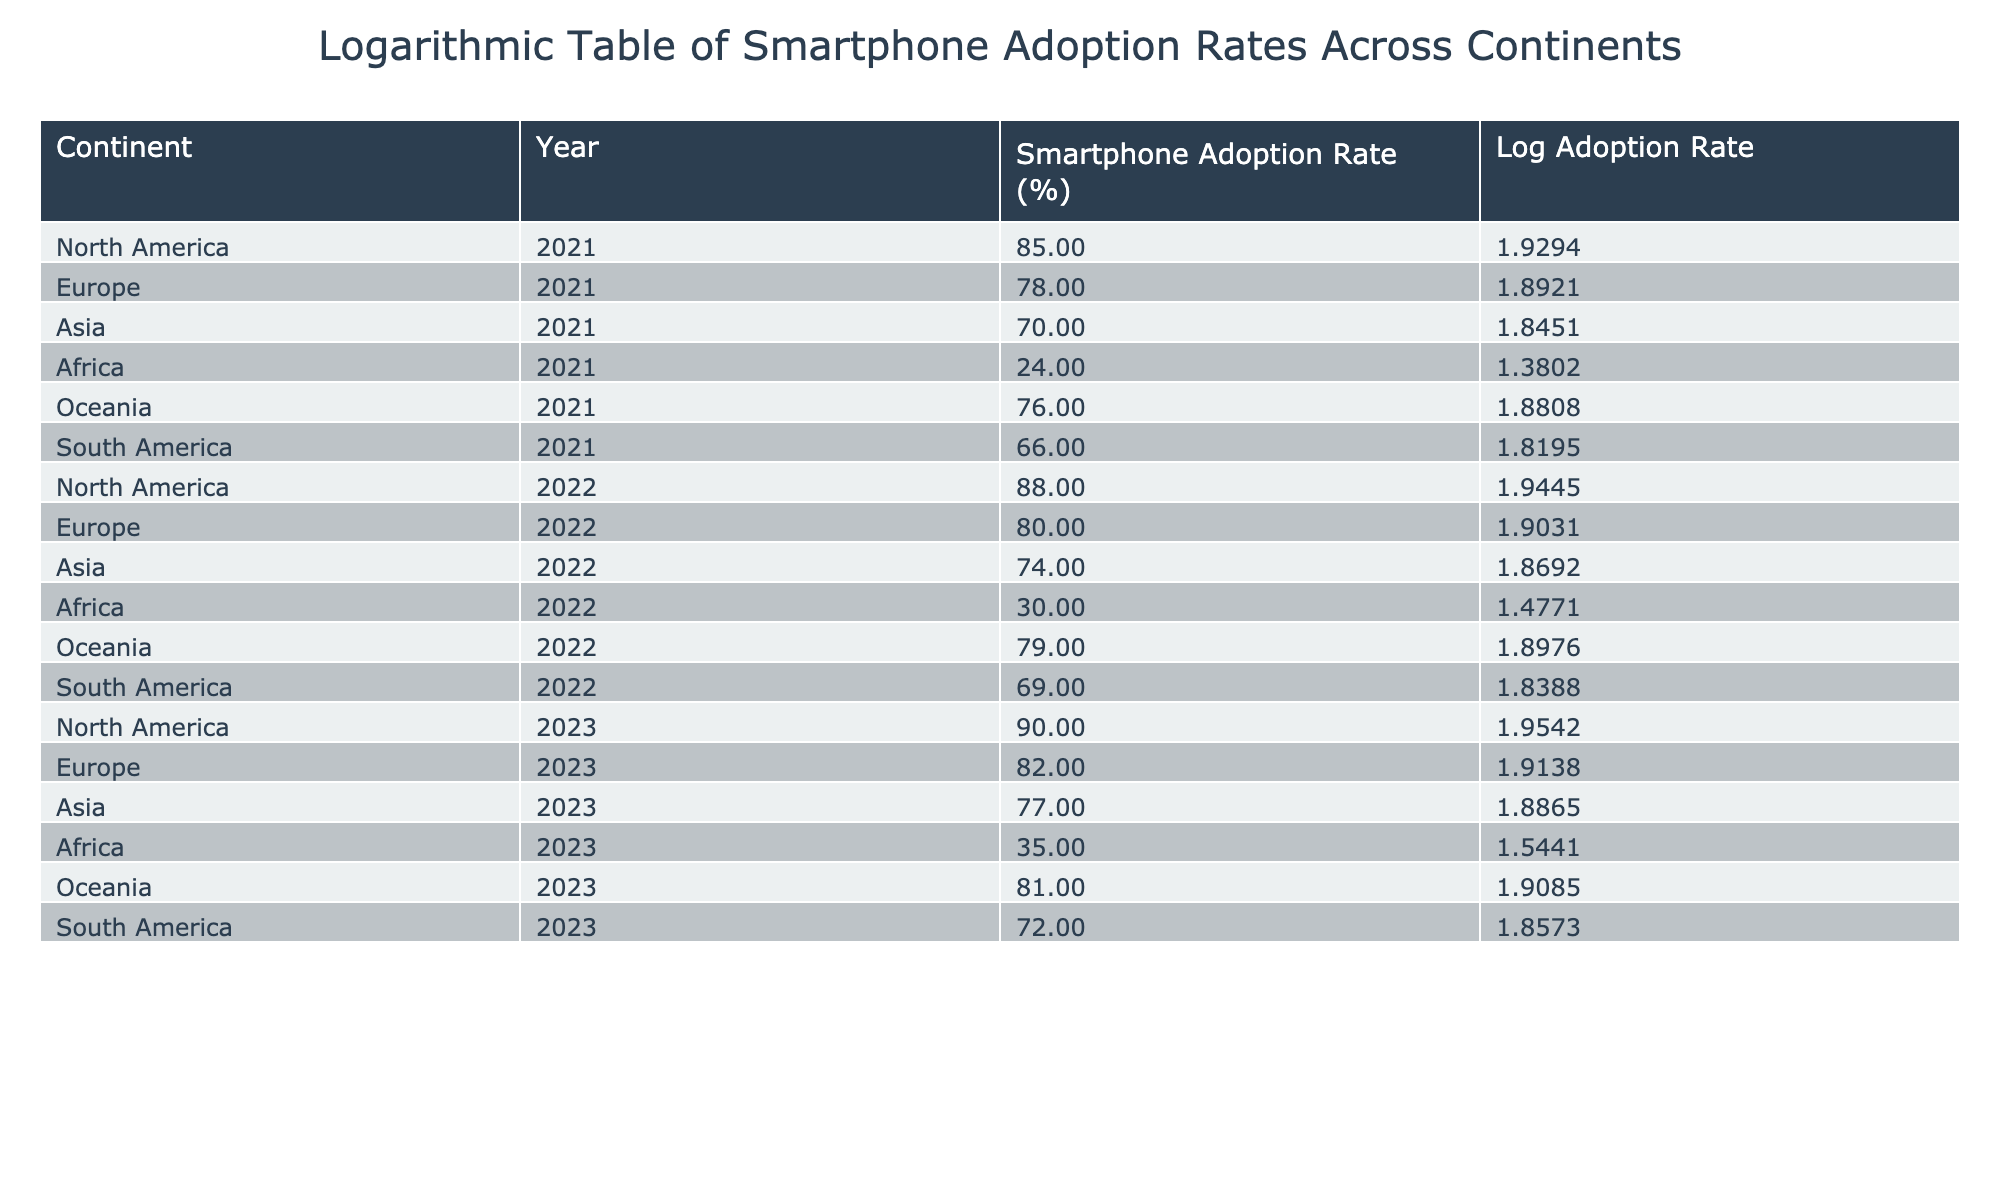What is the smartphone adoption rate in Africa for the year 2023? From the table, we can directly look for the row corresponding to Africa and the year 2023, which shows a smartphone adoption rate of 35%.
Answer: 35 Which continent had the highest smartphone adoption rate in 2022? Looking at the table for the year 2022, we see the highest value among the continents is 88% for North America.
Answer: North America What are the smartphone adoption rates for Asia in 2021 and 2022, and how much did it increase? In 2021, Asia's adoption rate is 70%, and in 2022 it is 74%. The increase can be calculated as 74% - 70% = 4%.
Answer: 4% Is the smartphone adoption rate in Europe higher in 2023 than in 2021? By comparing the values, Europe has a rate of 82% in 2023 and 78% in 2021. Since 82% is greater than 78%, the statement is true.
Answer: Yes What is the average smartphone adoption rate in Oceania for 2021, 2022, and 2023? The rates for Oceania are 76%, 79%, and 81% respectively. The average is calculated by summing these values: (76 + 79 + 81) / 3 = 78.67%.
Answer: 78.67 Which continent's smartphone adoption rate had the smallest increase from 2021 to 2022? Analyzing the differences: North America increased by 3%, Europe by 2%, Asia by 4%, Africa by 6%, Oceania by 3%, and South America by 3%. The smallest increase is in Europe (2%).
Answer: Europe Is it true that South America had a smartphone adoption rate less than 70% in 2021? Checking the table, South America's rate in 2021 is 66%. Thus, it is indeed less than 70%, making the statement true.
Answer: Yes What is the difference in the smartphone adoption rates between North America and Africa in 2023? North America has a smartphone adoption rate of 90%, while Africa has 35% in 2023. The difference is calculated as 90% - 35% = 55%.
Answer: 55 How much did Oceania's smartphone adoption rate increase from 2021 to 2023? Oceania's rates are 76% in 2021 and 81% in 2023. The increase is 81% - 76% = 5%.
Answer: 5 What will be the average smartphone adoption rate for all continents in 2023? Summing the 2023 rates: North America (90%) + Europe (82%) + Asia (77%) + Africa (35%) + Oceania (81%) + South America (72%) gives 437%. Dividing by the number of continents (6), we get an average of 72.83%.
Answer: 72.83 